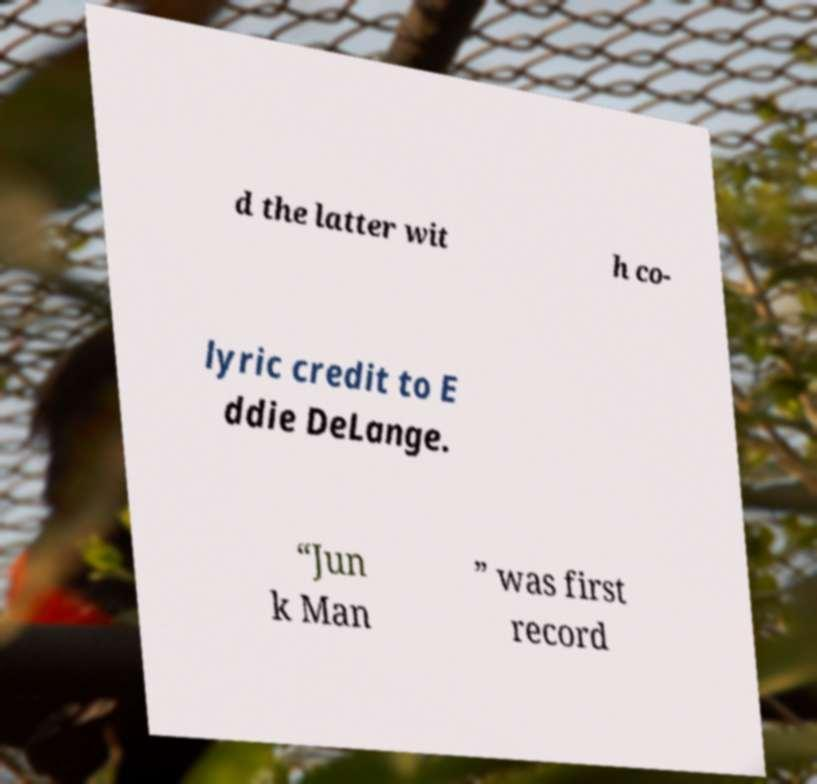Please identify and transcribe the text found in this image. d the latter wit h co- lyric credit to E ddie DeLange. “Jun k Man ” was first record 